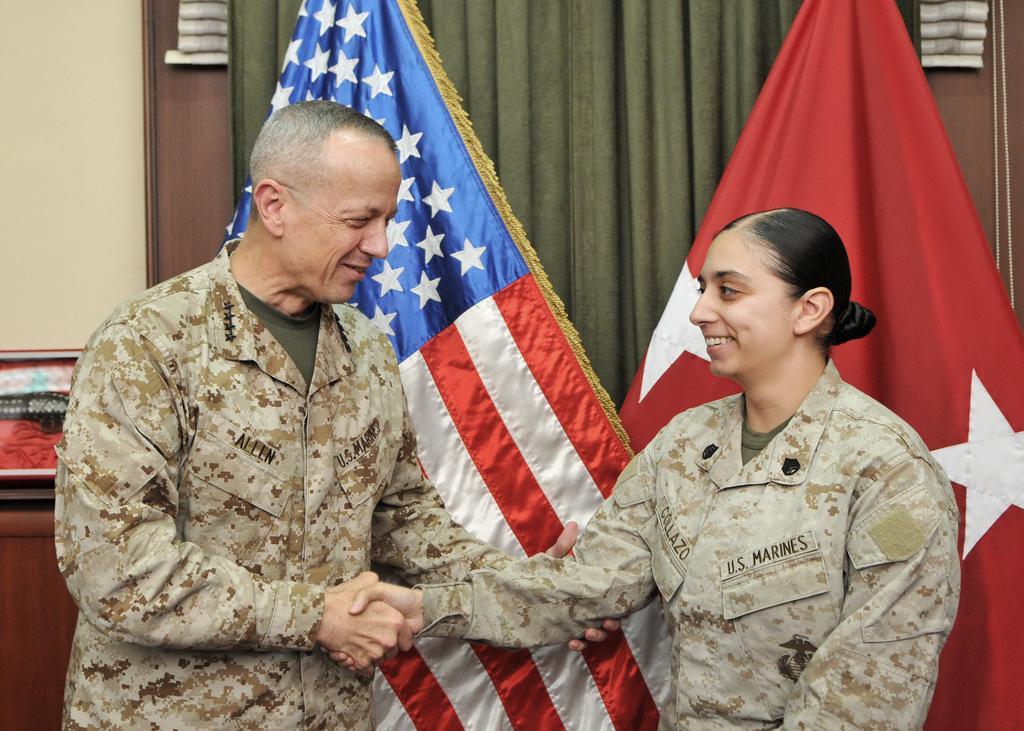How would you summarize this image in a sentence or two? On the left side, there is a person in uniform, shaking hands with a woman and holding hand of that woman who is smiling. In the background, there are two flags, a curtain, an object and a wall. 